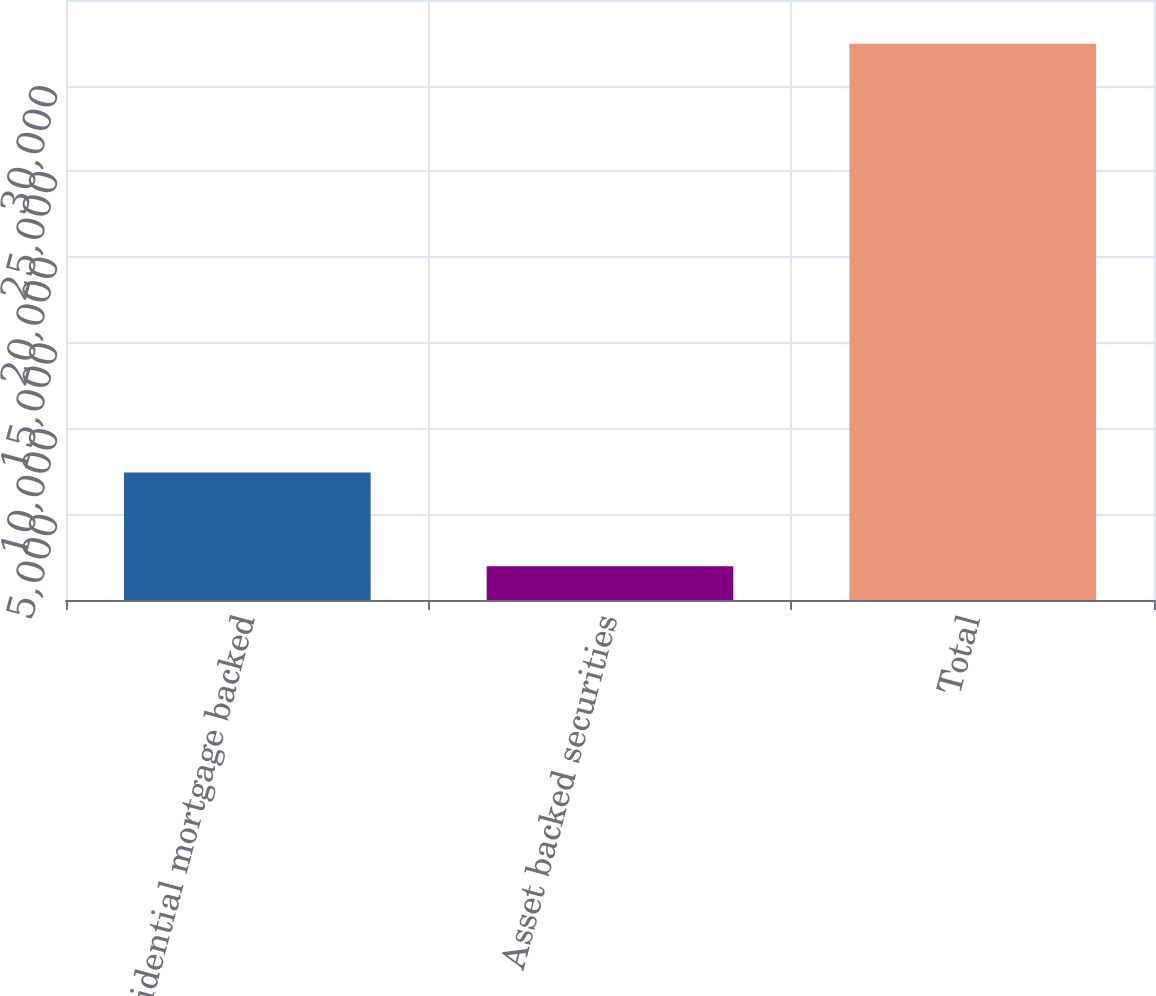Convert chart. <chart><loc_0><loc_0><loc_500><loc_500><bar_chart><fcel>Residential mortgage backed<fcel>Asset backed securities<fcel>Total<nl><fcel>7440<fcel>1968<fcel>32447<nl></chart> 